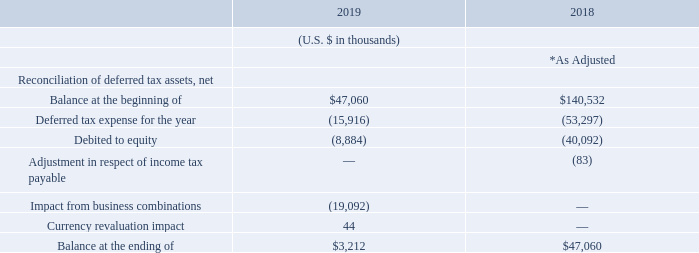* As adjusted to reflect the impact of the full retrospective adoption of IFRS 15. See Note 2 for further details.
The U.S. Tax Cuts and Jobs Act (the “Tax Act”) enacted on December 22, 2017 introduces a number of changes to U.S. income tax law. Among other changes, the Tax Act (i) reduces the U.S. federal corporate tax rate from 35% to 21%, (ii) enacts limitations regarding the deductibility of interest expense, (iii) modifies the provisions relating to the limitations on deductions for executive compensation of publicly traded corporations, (iv) imposes new limitations on the utilization of net operating loss arising in taxable years beginning after December 31, 2017, (v) repeals the corporate alternative minimum tax and provides for a refund of existing alternative minimum tax credits, and (vi) creates new taxes on certain foreign-sourced earnings and certain related-party payments, which are referred to as the global intangible low-taxed income tax and the base erosion tax, respectively.
As a result of the new U.S. federal statutory corporate tax rate of 21% contained within the Tax Act, the Group recorded non-cash charges of $16.9 million to tax expense and $16.9 million to equity to revalue the Group’s U.S. net deferred tax assets during fiscal year 2018.
In June 2019 and December 2017, as a result of the Group’s assessment of the realizability of its Australian and U.S. deferred tax assets, the Group recorded non-cash charges to tax expense of $54.7 million and $30.4 million, respectively, and $25.8 million to equity in December 2017 to reduce the carrying value of these assets. The assessment of the realizability of the Australian and U.S. deferred tax assets is based on all available positive and negative evidence. Such evidence includes, but is not limited to, recent cumulative earnings or losses, expectations of future taxable income by taxing jurisdiction, and the carry-forward periods available for the utilization of deferred tax assets. The Group will continue to assess and record any necessary changes to align its deferred tax assets to their realizable value.
In December 2017, the Group made changes to its corporate structure to include certain foreign subsidiaries in its U.S. consolidated tax group that resulted in the creation of certain deferred tax assets and liabilities, including a non-recognized deferred tax asset of $2.1 billion related to the fair market value of its intellectual property. The assets are included in the Group’s quarterly assessment and are only recognized to the extent they are determined to be realizable.
The impact on the net deferred tax asset from business combinations of $19.1 million in fiscal year 2019 represents the net deferred tax assets and liabilities recognized as a result of the acquisition of OpsGenie. The Group acquired net operating loss carryforward deferred tax assets of approximately $1.8 million from OpsGenie. The Group also recognized deferred tax liabilities of approximately $19.6 million primarily related to acquired intangibles from OpsGenie, the amortization of which will not be deductible from future taxable profits.
When was the U.S. Tax Cuts and Jobs Act enacted? December 22, 2017. What is the new U.S. federal corporate tax rate after the Tax Act was enacted? 21%. What is the  Balance at the beginning of 2019?
Answer scale should be: thousand. $47,060. What is the change in the ending balance between fiscal years 2018 and 2019?
Answer scale should be: thousand. 3,212-47,060
Answer: -43848. What is the average deferred tax expense for fiscal years 2018 and 2019?
Answer scale should be: thousand. -(15,916+53,297)/2
Answer: -34606.5. What is the percentage change of deferred tax expenses between fiscal year 2018 to 2019?
Answer scale should be: percent. (-15,916-(-53,297))/(-53,297)
Answer: -70.14. 